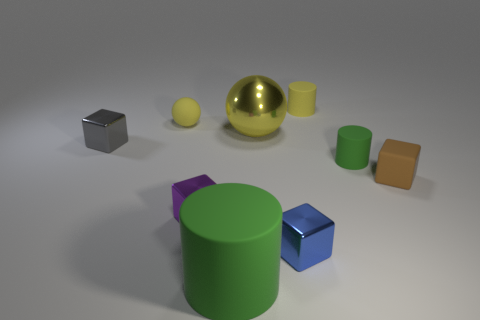What shape is the tiny brown object that is made of the same material as the small green thing? cube 